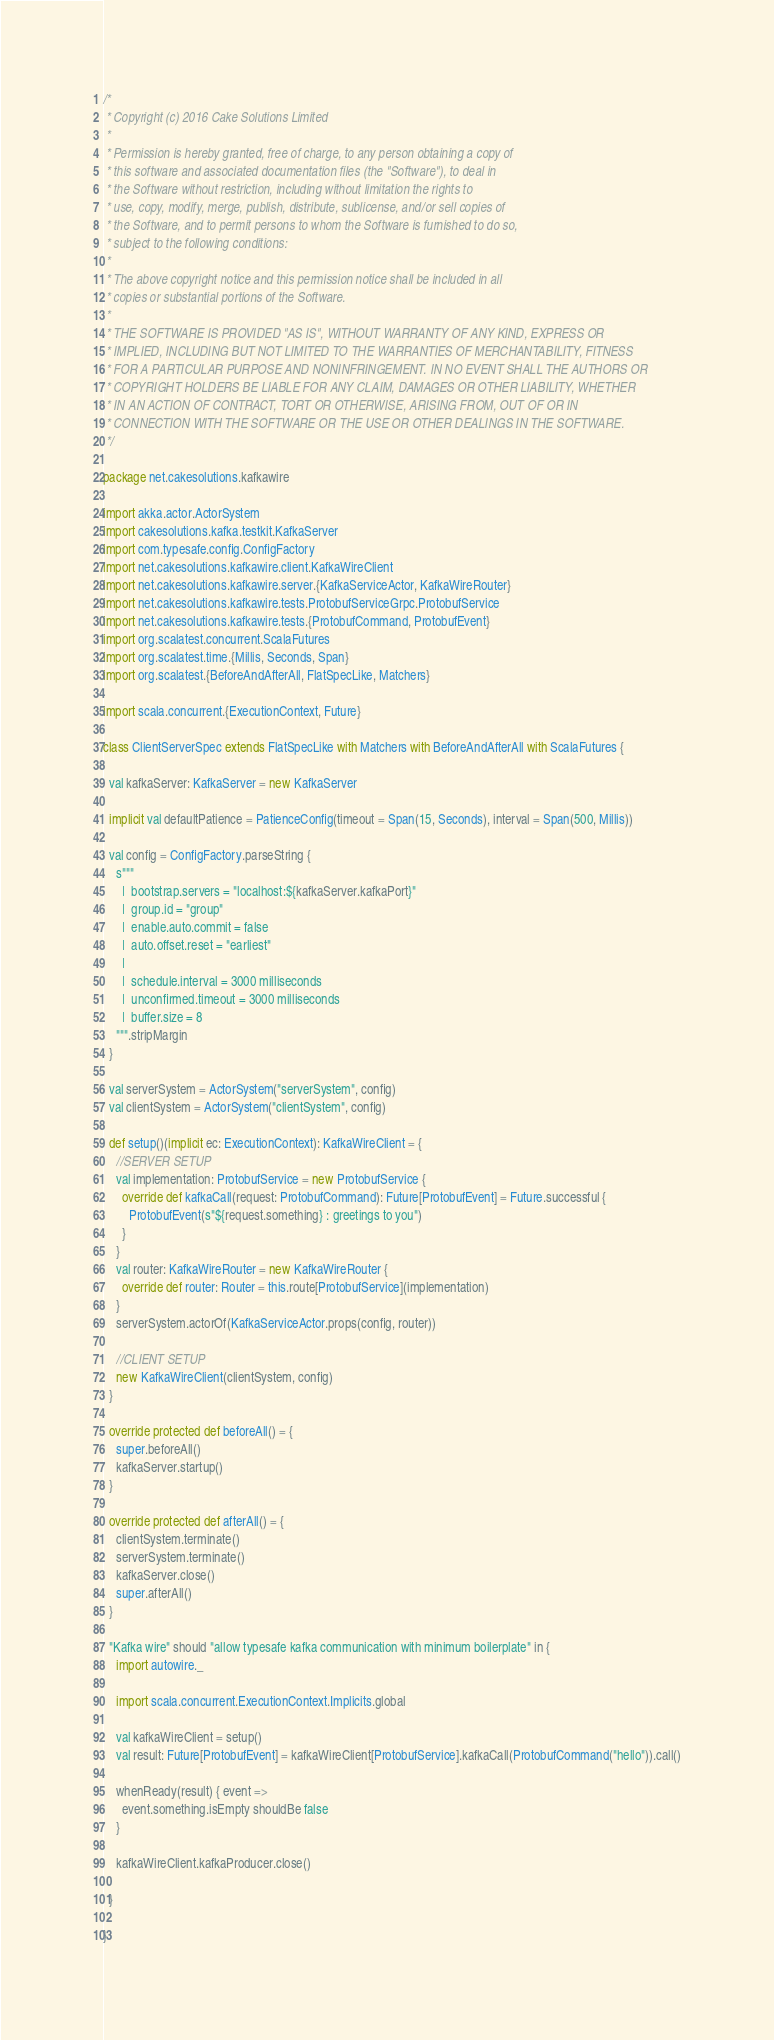<code> <loc_0><loc_0><loc_500><loc_500><_Scala_>/*
 * Copyright (c) 2016 Cake Solutions Limited
 *
 * Permission is hereby granted, free of charge, to any person obtaining a copy of
 * this software and associated documentation files (the "Software"), to deal in
 * the Software without restriction, including without limitation the rights to
 * use, copy, modify, merge, publish, distribute, sublicense, and/or sell copies of
 * the Software, and to permit persons to whom the Software is furnished to do so,
 * subject to the following conditions:
 *
 * The above copyright notice and this permission notice shall be included in all
 * copies or substantial portions of the Software.
 *
 * THE SOFTWARE IS PROVIDED "AS IS", WITHOUT WARRANTY OF ANY KIND, EXPRESS OR
 * IMPLIED, INCLUDING BUT NOT LIMITED TO THE WARRANTIES OF MERCHANTABILITY, FITNESS
 * FOR A PARTICULAR PURPOSE AND NONINFRINGEMENT. IN NO EVENT SHALL THE AUTHORS OR
 * COPYRIGHT HOLDERS BE LIABLE FOR ANY CLAIM, DAMAGES OR OTHER LIABILITY, WHETHER
 * IN AN ACTION OF CONTRACT, TORT OR OTHERWISE, ARISING FROM, OUT OF OR IN
 * CONNECTION WITH THE SOFTWARE OR THE USE OR OTHER DEALINGS IN THE SOFTWARE.
 */

package net.cakesolutions.kafkawire

import akka.actor.ActorSystem
import cakesolutions.kafka.testkit.KafkaServer
import com.typesafe.config.ConfigFactory
import net.cakesolutions.kafkawire.client.KafkaWireClient
import net.cakesolutions.kafkawire.server.{KafkaServiceActor, KafkaWireRouter}
import net.cakesolutions.kafkawire.tests.ProtobufServiceGrpc.ProtobufService
import net.cakesolutions.kafkawire.tests.{ProtobufCommand, ProtobufEvent}
import org.scalatest.concurrent.ScalaFutures
import org.scalatest.time.{Millis, Seconds, Span}
import org.scalatest.{BeforeAndAfterAll, FlatSpecLike, Matchers}

import scala.concurrent.{ExecutionContext, Future}

class ClientServerSpec extends FlatSpecLike with Matchers with BeforeAndAfterAll with ScalaFutures {

  val kafkaServer: KafkaServer = new KafkaServer

  implicit val defaultPatience = PatienceConfig(timeout = Span(15, Seconds), interval = Span(500, Millis))

  val config = ConfigFactory.parseString {
    s"""
      |  bootstrap.servers = "localhost:${kafkaServer.kafkaPort}"
      |  group.id = "group"
      |  enable.auto.commit = false
      |  auto.offset.reset = "earliest"
      |
      |  schedule.interval = 3000 milliseconds
      |  unconfirmed.timeout = 3000 milliseconds
      |  buffer.size = 8
    """.stripMargin
  }

  val serverSystem = ActorSystem("serverSystem", config)
  val clientSystem = ActorSystem("clientSystem", config)

  def setup()(implicit ec: ExecutionContext): KafkaWireClient = {
    //SERVER SETUP
    val implementation: ProtobufService = new ProtobufService {
      override def kafkaCall(request: ProtobufCommand): Future[ProtobufEvent] = Future.successful {
        ProtobufEvent(s"${request.something} : greetings to you")
      }
    }
    val router: KafkaWireRouter = new KafkaWireRouter {
      override def router: Router = this.route[ProtobufService](implementation)
    }
    serverSystem.actorOf(KafkaServiceActor.props(config, router))

    //CLIENT SETUP
    new KafkaWireClient(clientSystem, config)
  }

  override protected def beforeAll() = {
    super.beforeAll()
    kafkaServer.startup()
  }

  override protected def afterAll() = {
    clientSystem.terminate()
    serverSystem.terminate()
    kafkaServer.close()
    super.afterAll()
  }

  "Kafka wire" should "allow typesafe kafka communication with minimum boilerplate" in {
    import autowire._

    import scala.concurrent.ExecutionContext.Implicits.global

    val kafkaWireClient = setup()
    val result: Future[ProtobufEvent] = kafkaWireClient[ProtobufService].kafkaCall(ProtobufCommand("hello")).call()

    whenReady(result) { event =>
      event.something.isEmpty shouldBe false
    }

    kafkaWireClient.kafkaProducer.close()

  }

}
</code> 